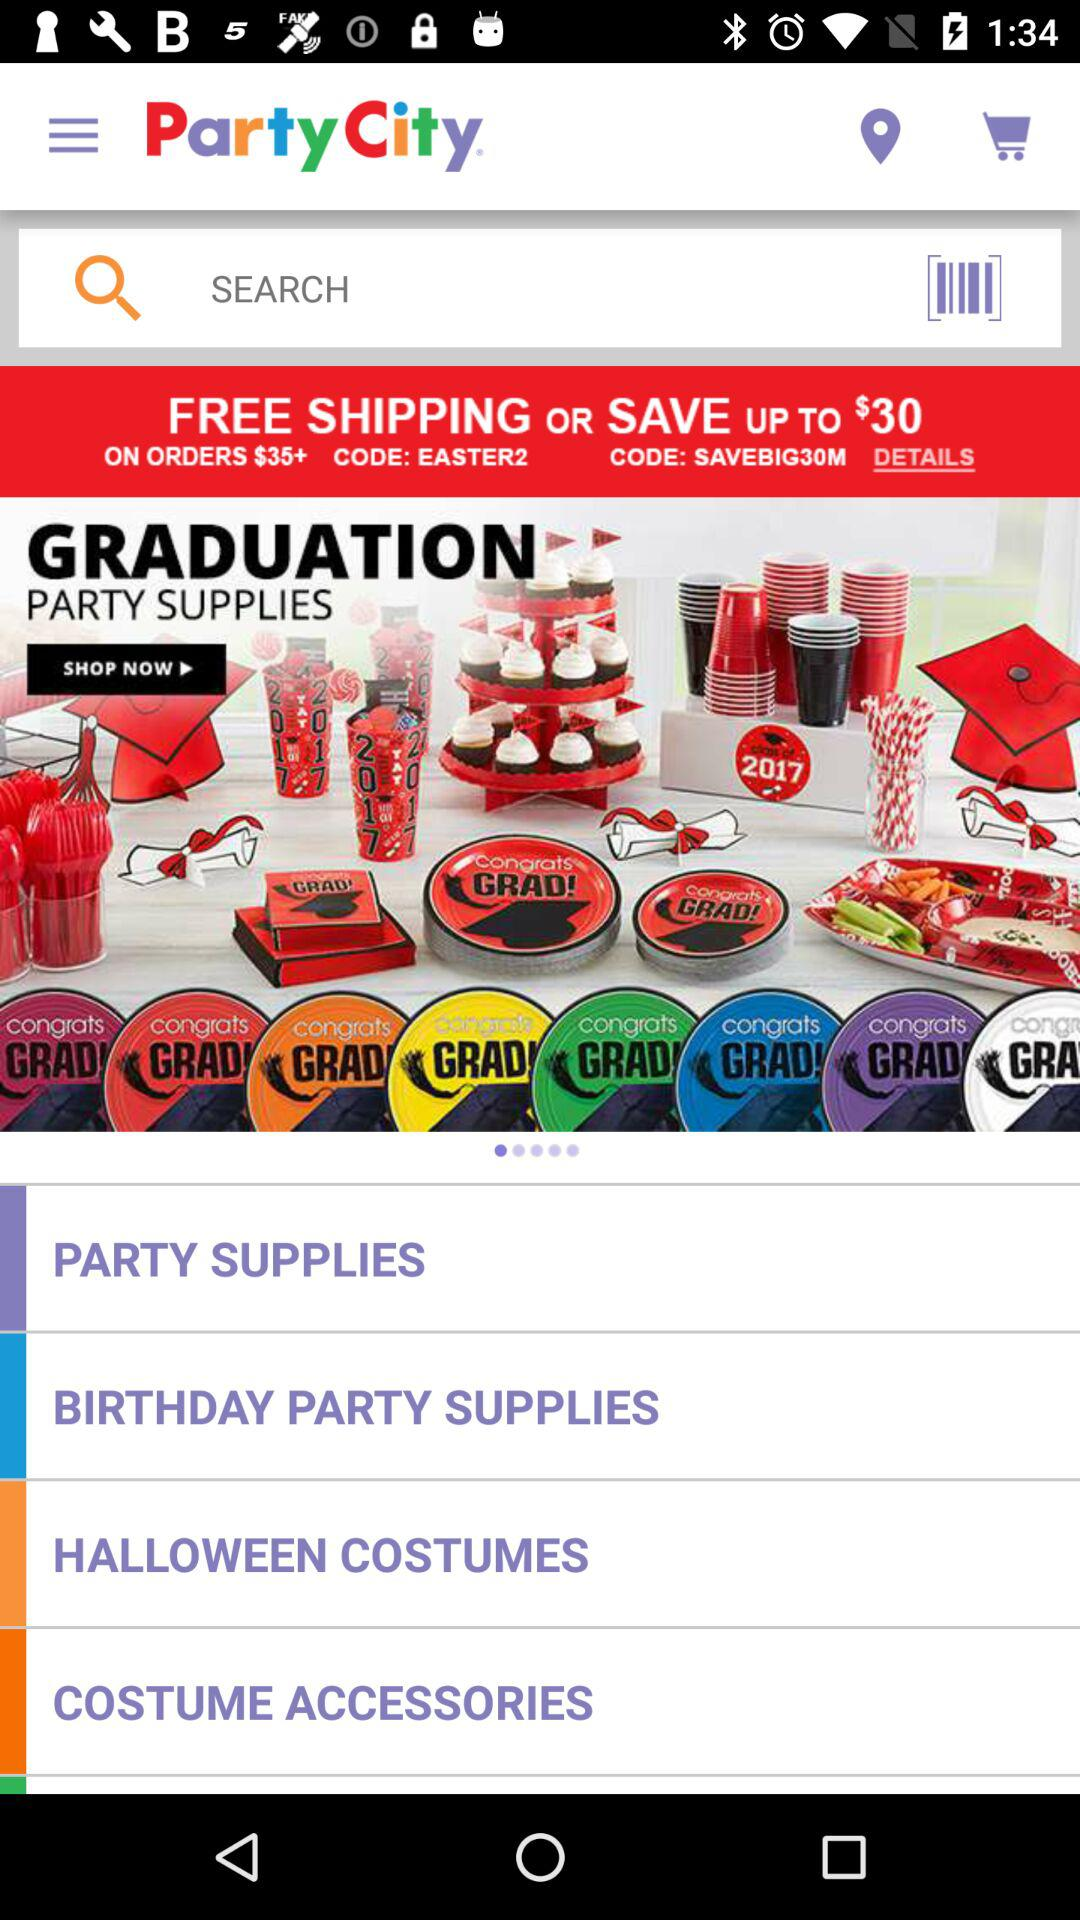What is the code for free shipping? The code for free shipping is EASTER2. 